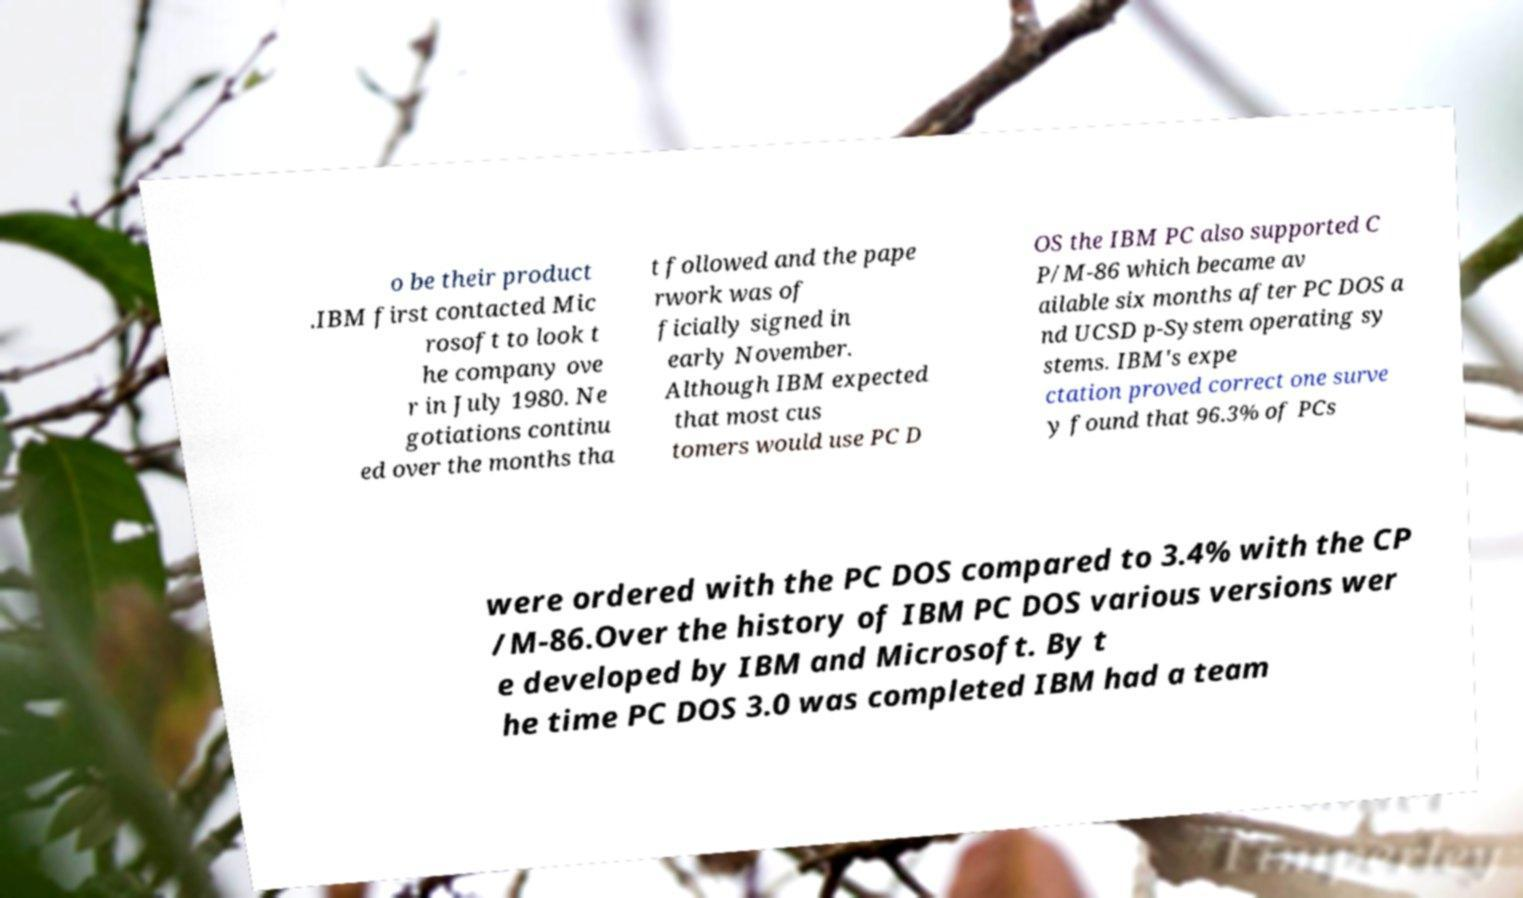There's text embedded in this image that I need extracted. Can you transcribe it verbatim? o be their product .IBM first contacted Mic rosoft to look t he company ove r in July 1980. Ne gotiations continu ed over the months tha t followed and the pape rwork was of ficially signed in early November. Although IBM expected that most cus tomers would use PC D OS the IBM PC also supported C P/M-86 which became av ailable six months after PC DOS a nd UCSD p-System operating sy stems. IBM's expe ctation proved correct one surve y found that 96.3% of PCs were ordered with the PC DOS compared to 3.4% with the CP /M-86.Over the history of IBM PC DOS various versions wer e developed by IBM and Microsoft. By t he time PC DOS 3.0 was completed IBM had a team 